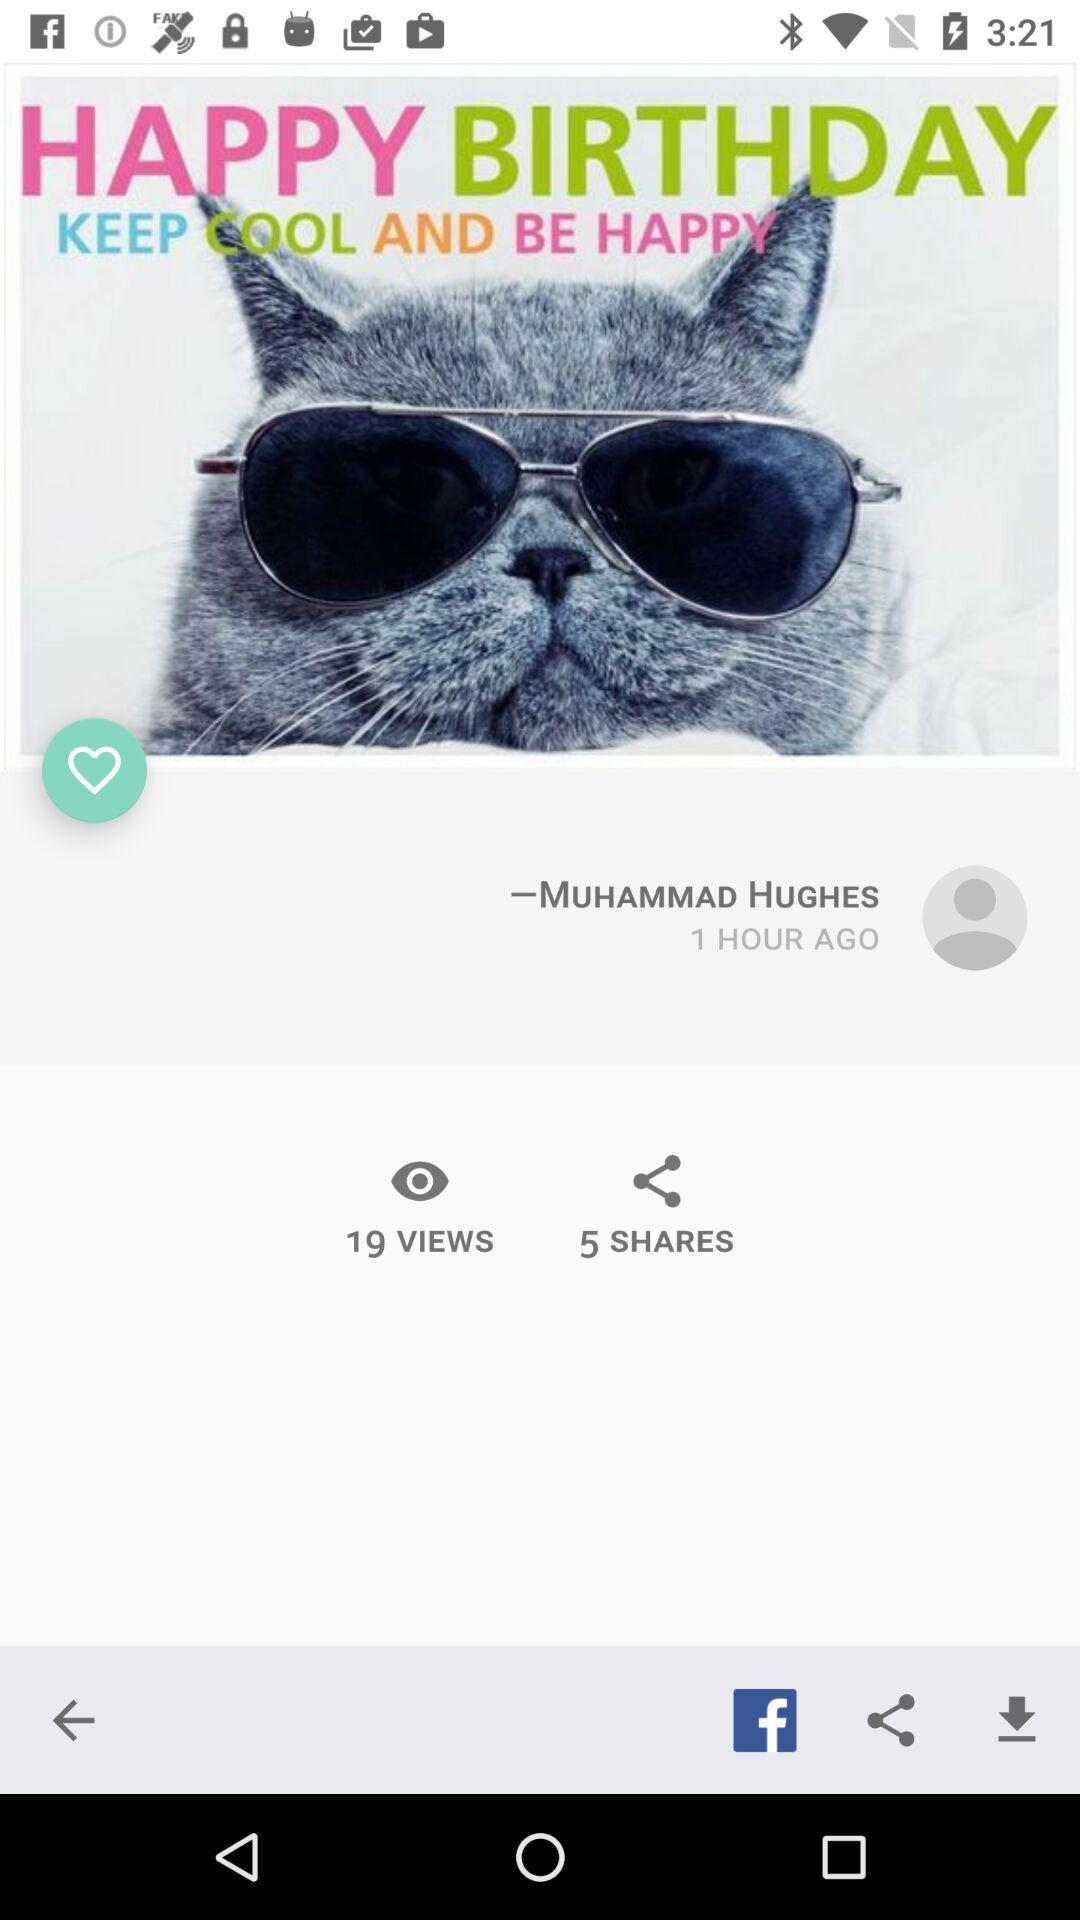How many hours ago was the post uploaded?
Answer the question using a single word or phrase. 1 